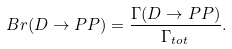<formula> <loc_0><loc_0><loc_500><loc_500>B r ( D \to P P ) = \frac { \Gamma ( D \to P P ) } { \Gamma _ { t o t } } .</formula> 